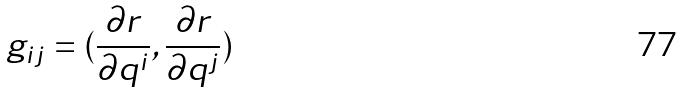Convert formula to latex. <formula><loc_0><loc_0><loc_500><loc_500>g _ { i j } = ( \frac { \partial r } { \partial q ^ { i } } , \frac { \partial r } { \partial q ^ { j } } )</formula> 